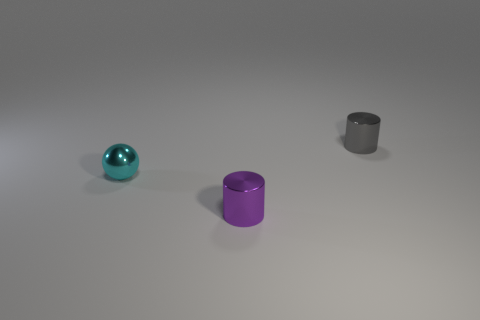The other small cylinder that is the same material as the gray cylinder is what color?
Make the answer very short. Purple. There is a small cyan metallic object that is to the left of the cylinder that is behind the purple metal object; how many small purple things are on the left side of it?
Keep it short and to the point. 0. Are there any other things that are the same shape as the tiny purple shiny object?
Offer a terse response. Yes. How many objects are either objects that are in front of the small cyan metal sphere or large green metal things?
Offer a terse response. 1. Do the object that is on the right side of the small purple metal object and the tiny sphere have the same color?
Provide a succinct answer. No. There is a cyan shiny object left of the small cylinder that is in front of the gray metal thing; what shape is it?
Your answer should be very brief. Sphere. Is the number of cylinders that are behind the cyan metallic ball less than the number of metal spheres in front of the small purple thing?
Provide a short and direct response. No. There is a purple shiny object that is the same shape as the gray thing; what is its size?
Your response must be concise. Small. Is there any other thing that is the same size as the gray cylinder?
Give a very brief answer. Yes. How many things are either things right of the tiny purple metal cylinder or shiny cylinders behind the purple cylinder?
Your answer should be compact. 1. 